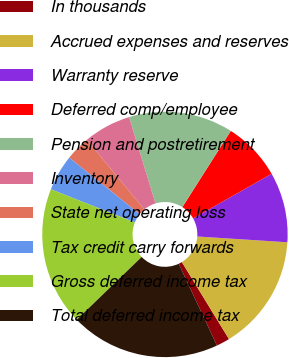Convert chart to OTSL. <chart><loc_0><loc_0><loc_500><loc_500><pie_chart><fcel>In thousands<fcel>Accrued expenses and reserves<fcel>Warranty reserve<fcel>Deferred comp/employee<fcel>Pension and postretirement<fcel>Inventory<fcel>State net operating loss<fcel>Tax credit carry forwards<fcel>Gross deferred income tax<fcel>Total deferred income tax<nl><fcel>1.77%<fcel>15.24%<fcel>9.25%<fcel>7.75%<fcel>13.74%<fcel>6.26%<fcel>3.26%<fcel>4.76%<fcel>18.23%<fcel>19.73%<nl></chart> 